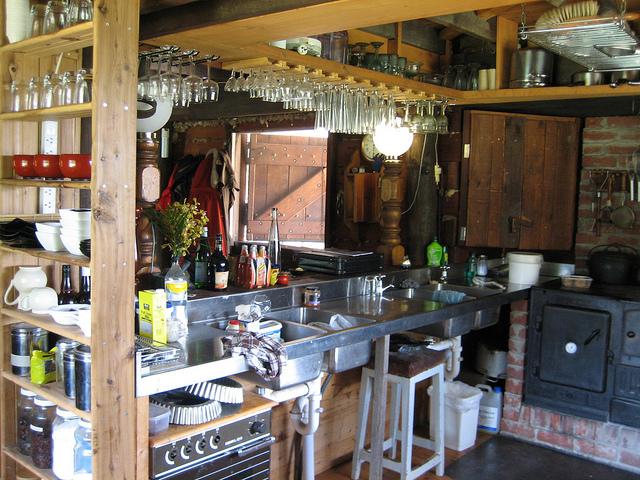Is there an oven in this picture?
Write a very short answer. Yes. Are glasses hanging?
Answer briefly. Yes. Is this a restaurant kitchen?
Concise answer only. Yes. 